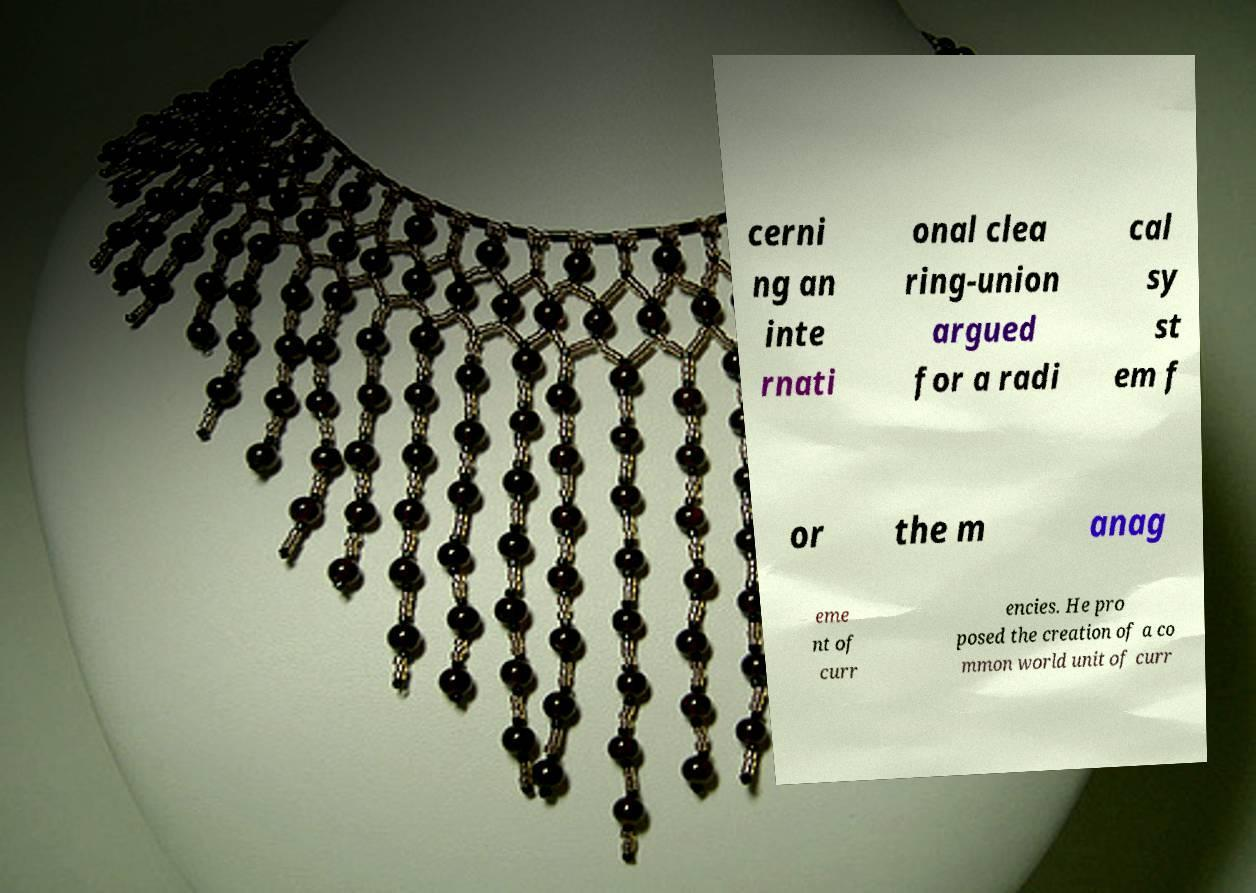For documentation purposes, I need the text within this image transcribed. Could you provide that? cerni ng an inte rnati onal clea ring-union argued for a radi cal sy st em f or the m anag eme nt of curr encies. He pro posed the creation of a co mmon world unit of curr 